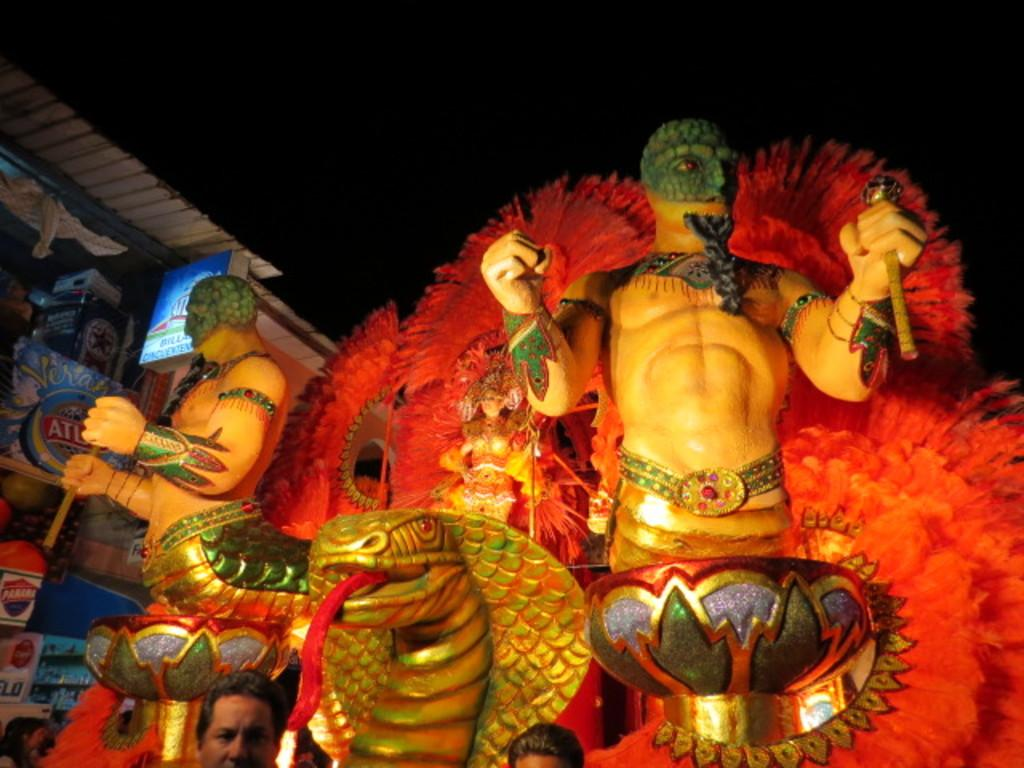How many statues are present in the image? There are two statues in the image. What colors are the statues? One statue is yellow in color, and the other statue is green in color. What can be seen in the background of the image? The background of the image is orange in color. What type of nut can be seen falling from the mind of the green statue in the image? There is no nut or reference to a mind in the image; it features two statues, one yellow and one green, with an orange background. 